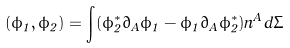Convert formula to latex. <formula><loc_0><loc_0><loc_500><loc_500>( \phi _ { 1 } , \phi _ { 2 } ) = \int ( \phi ^ { * } _ { 2 } \partial _ { A } \phi _ { 1 } - \phi _ { 1 } \partial _ { A } \phi _ { 2 } ^ { * } ) n ^ { A } d \Sigma</formula> 